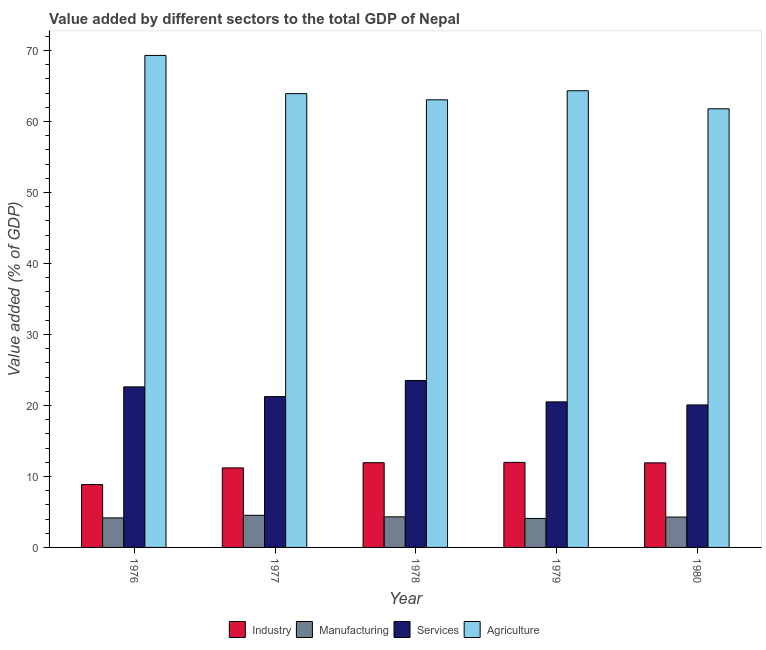How many groups of bars are there?
Provide a succinct answer. 5. Are the number of bars on each tick of the X-axis equal?
Offer a very short reply. Yes. What is the label of the 3rd group of bars from the left?
Provide a succinct answer. 1978. What is the value added by services sector in 1976?
Offer a very short reply. 22.61. Across all years, what is the maximum value added by services sector?
Offer a terse response. 23.51. Across all years, what is the minimum value added by services sector?
Your answer should be compact. 20.07. In which year was the value added by services sector maximum?
Your response must be concise. 1978. In which year was the value added by manufacturing sector minimum?
Ensure brevity in your answer.  1979. What is the total value added by industrial sector in the graph?
Your answer should be compact. 55.89. What is the difference between the value added by services sector in 1976 and that in 1980?
Your response must be concise. 2.54. What is the difference between the value added by agricultural sector in 1976 and the value added by industrial sector in 1980?
Give a very brief answer. 7.52. What is the average value added by services sector per year?
Provide a short and direct response. 21.59. In how many years, is the value added by agricultural sector greater than 64 %?
Offer a very short reply. 2. What is the ratio of the value added by agricultural sector in 1978 to that in 1979?
Offer a very short reply. 0.98. Is the value added by industrial sector in 1976 less than that in 1978?
Provide a succinct answer. Yes. Is the difference between the value added by agricultural sector in 1977 and 1978 greater than the difference between the value added by services sector in 1977 and 1978?
Give a very brief answer. No. What is the difference between the highest and the second highest value added by industrial sector?
Your answer should be very brief. 0.04. What is the difference between the highest and the lowest value added by manufacturing sector?
Make the answer very short. 0.45. Is it the case that in every year, the sum of the value added by services sector and value added by industrial sector is greater than the sum of value added by agricultural sector and value added by manufacturing sector?
Your answer should be compact. No. What does the 2nd bar from the left in 1977 represents?
Ensure brevity in your answer.  Manufacturing. What does the 2nd bar from the right in 1977 represents?
Ensure brevity in your answer.  Services. Is it the case that in every year, the sum of the value added by industrial sector and value added by manufacturing sector is greater than the value added by services sector?
Your answer should be very brief. No. Are all the bars in the graph horizontal?
Give a very brief answer. No. Does the graph contain grids?
Ensure brevity in your answer.  No. How are the legend labels stacked?
Your response must be concise. Horizontal. What is the title of the graph?
Ensure brevity in your answer.  Value added by different sectors to the total GDP of Nepal. What is the label or title of the X-axis?
Give a very brief answer. Year. What is the label or title of the Y-axis?
Your answer should be compact. Value added (% of GDP). What is the Value added (% of GDP) in Industry in 1976?
Your response must be concise. 8.86. What is the Value added (% of GDP) in Manufacturing in 1976?
Your response must be concise. 4.16. What is the Value added (% of GDP) of Services in 1976?
Give a very brief answer. 22.61. What is the Value added (% of GDP) of Agriculture in 1976?
Your response must be concise. 69.29. What is the Value added (% of GDP) in Industry in 1977?
Your response must be concise. 11.2. What is the Value added (% of GDP) of Manufacturing in 1977?
Give a very brief answer. 4.53. What is the Value added (% of GDP) of Services in 1977?
Offer a terse response. 21.24. What is the Value added (% of GDP) of Agriculture in 1977?
Offer a very short reply. 63.91. What is the Value added (% of GDP) of Industry in 1978?
Make the answer very short. 11.93. What is the Value added (% of GDP) in Manufacturing in 1978?
Keep it short and to the point. 4.31. What is the Value added (% of GDP) in Services in 1978?
Your response must be concise. 23.51. What is the Value added (% of GDP) of Agriculture in 1978?
Provide a short and direct response. 63.04. What is the Value added (% of GDP) of Industry in 1979?
Provide a short and direct response. 11.98. What is the Value added (% of GDP) of Manufacturing in 1979?
Make the answer very short. 4.08. What is the Value added (% of GDP) of Services in 1979?
Keep it short and to the point. 20.5. What is the Value added (% of GDP) in Agriculture in 1979?
Keep it short and to the point. 64.32. What is the Value added (% of GDP) in Industry in 1980?
Your answer should be very brief. 11.92. What is the Value added (% of GDP) of Manufacturing in 1980?
Offer a terse response. 4.28. What is the Value added (% of GDP) of Services in 1980?
Your response must be concise. 20.07. What is the Value added (% of GDP) in Agriculture in 1980?
Make the answer very short. 61.77. Across all years, what is the maximum Value added (% of GDP) of Industry?
Provide a short and direct response. 11.98. Across all years, what is the maximum Value added (% of GDP) in Manufacturing?
Your answer should be compact. 4.53. Across all years, what is the maximum Value added (% of GDP) of Services?
Your answer should be compact. 23.51. Across all years, what is the maximum Value added (% of GDP) of Agriculture?
Offer a terse response. 69.29. Across all years, what is the minimum Value added (% of GDP) of Industry?
Provide a short and direct response. 8.86. Across all years, what is the minimum Value added (% of GDP) of Manufacturing?
Your answer should be very brief. 4.08. Across all years, what is the minimum Value added (% of GDP) of Services?
Your answer should be compact. 20.07. Across all years, what is the minimum Value added (% of GDP) in Agriculture?
Your answer should be compact. 61.77. What is the total Value added (% of GDP) of Industry in the graph?
Give a very brief answer. 55.89. What is the total Value added (% of GDP) in Manufacturing in the graph?
Your response must be concise. 21.35. What is the total Value added (% of GDP) in Services in the graph?
Provide a succinct answer. 107.93. What is the total Value added (% of GDP) of Agriculture in the graph?
Offer a very short reply. 322.34. What is the difference between the Value added (% of GDP) of Industry in 1976 and that in 1977?
Provide a succinct answer. -2.35. What is the difference between the Value added (% of GDP) of Manufacturing in 1976 and that in 1977?
Make the answer very short. -0.37. What is the difference between the Value added (% of GDP) in Services in 1976 and that in 1977?
Keep it short and to the point. 1.37. What is the difference between the Value added (% of GDP) of Agriculture in 1976 and that in 1977?
Provide a succinct answer. 5.38. What is the difference between the Value added (% of GDP) in Industry in 1976 and that in 1978?
Your response must be concise. -3.08. What is the difference between the Value added (% of GDP) in Manufacturing in 1976 and that in 1978?
Give a very brief answer. -0.15. What is the difference between the Value added (% of GDP) in Services in 1976 and that in 1978?
Your response must be concise. -0.9. What is the difference between the Value added (% of GDP) in Agriculture in 1976 and that in 1978?
Provide a short and direct response. 6.25. What is the difference between the Value added (% of GDP) in Industry in 1976 and that in 1979?
Ensure brevity in your answer.  -3.12. What is the difference between the Value added (% of GDP) in Manufacturing in 1976 and that in 1979?
Your response must be concise. 0.08. What is the difference between the Value added (% of GDP) in Services in 1976 and that in 1979?
Give a very brief answer. 2.11. What is the difference between the Value added (% of GDP) of Agriculture in 1976 and that in 1979?
Your answer should be compact. 4.97. What is the difference between the Value added (% of GDP) of Industry in 1976 and that in 1980?
Your answer should be compact. -3.06. What is the difference between the Value added (% of GDP) in Manufacturing in 1976 and that in 1980?
Give a very brief answer. -0.12. What is the difference between the Value added (% of GDP) in Services in 1976 and that in 1980?
Your answer should be compact. 2.54. What is the difference between the Value added (% of GDP) in Agriculture in 1976 and that in 1980?
Give a very brief answer. 7.52. What is the difference between the Value added (% of GDP) in Industry in 1977 and that in 1978?
Your response must be concise. -0.73. What is the difference between the Value added (% of GDP) of Manufacturing in 1977 and that in 1978?
Your answer should be very brief. 0.22. What is the difference between the Value added (% of GDP) in Services in 1977 and that in 1978?
Ensure brevity in your answer.  -2.27. What is the difference between the Value added (% of GDP) in Agriculture in 1977 and that in 1978?
Your answer should be very brief. 0.87. What is the difference between the Value added (% of GDP) in Industry in 1977 and that in 1979?
Make the answer very short. -0.78. What is the difference between the Value added (% of GDP) in Manufacturing in 1977 and that in 1979?
Your response must be concise. 0.45. What is the difference between the Value added (% of GDP) of Services in 1977 and that in 1979?
Your answer should be very brief. 0.74. What is the difference between the Value added (% of GDP) in Agriculture in 1977 and that in 1979?
Make the answer very short. -0.41. What is the difference between the Value added (% of GDP) of Industry in 1977 and that in 1980?
Your answer should be very brief. -0.71. What is the difference between the Value added (% of GDP) in Manufacturing in 1977 and that in 1980?
Your answer should be very brief. 0.25. What is the difference between the Value added (% of GDP) in Services in 1977 and that in 1980?
Your answer should be compact. 1.18. What is the difference between the Value added (% of GDP) of Agriculture in 1977 and that in 1980?
Offer a very short reply. 2.14. What is the difference between the Value added (% of GDP) in Industry in 1978 and that in 1979?
Your answer should be very brief. -0.04. What is the difference between the Value added (% of GDP) in Manufacturing in 1978 and that in 1979?
Offer a very short reply. 0.23. What is the difference between the Value added (% of GDP) in Services in 1978 and that in 1979?
Offer a terse response. 3.01. What is the difference between the Value added (% of GDP) in Agriculture in 1978 and that in 1979?
Offer a very short reply. -1.28. What is the difference between the Value added (% of GDP) in Industry in 1978 and that in 1980?
Make the answer very short. 0.02. What is the difference between the Value added (% of GDP) of Manufacturing in 1978 and that in 1980?
Ensure brevity in your answer.  0.03. What is the difference between the Value added (% of GDP) of Services in 1978 and that in 1980?
Ensure brevity in your answer.  3.44. What is the difference between the Value added (% of GDP) of Agriculture in 1978 and that in 1980?
Your answer should be very brief. 1.27. What is the difference between the Value added (% of GDP) in Industry in 1979 and that in 1980?
Provide a short and direct response. 0.06. What is the difference between the Value added (% of GDP) of Manufacturing in 1979 and that in 1980?
Make the answer very short. -0.2. What is the difference between the Value added (% of GDP) in Services in 1979 and that in 1980?
Your answer should be compact. 0.43. What is the difference between the Value added (% of GDP) of Agriculture in 1979 and that in 1980?
Your answer should be very brief. 2.55. What is the difference between the Value added (% of GDP) in Industry in 1976 and the Value added (% of GDP) in Manufacturing in 1977?
Offer a very short reply. 4.33. What is the difference between the Value added (% of GDP) of Industry in 1976 and the Value added (% of GDP) of Services in 1977?
Provide a succinct answer. -12.39. What is the difference between the Value added (% of GDP) of Industry in 1976 and the Value added (% of GDP) of Agriculture in 1977?
Keep it short and to the point. -55.06. What is the difference between the Value added (% of GDP) of Manufacturing in 1976 and the Value added (% of GDP) of Services in 1977?
Give a very brief answer. -17.08. What is the difference between the Value added (% of GDP) of Manufacturing in 1976 and the Value added (% of GDP) of Agriculture in 1977?
Offer a terse response. -59.75. What is the difference between the Value added (% of GDP) of Services in 1976 and the Value added (% of GDP) of Agriculture in 1977?
Offer a very short reply. -41.3. What is the difference between the Value added (% of GDP) of Industry in 1976 and the Value added (% of GDP) of Manufacturing in 1978?
Offer a terse response. 4.55. What is the difference between the Value added (% of GDP) of Industry in 1976 and the Value added (% of GDP) of Services in 1978?
Provide a succinct answer. -14.66. What is the difference between the Value added (% of GDP) of Industry in 1976 and the Value added (% of GDP) of Agriculture in 1978?
Provide a succinct answer. -54.19. What is the difference between the Value added (% of GDP) in Manufacturing in 1976 and the Value added (% of GDP) in Services in 1978?
Provide a succinct answer. -19.35. What is the difference between the Value added (% of GDP) of Manufacturing in 1976 and the Value added (% of GDP) of Agriculture in 1978?
Make the answer very short. -58.88. What is the difference between the Value added (% of GDP) in Services in 1976 and the Value added (% of GDP) in Agriculture in 1978?
Offer a very short reply. -40.43. What is the difference between the Value added (% of GDP) of Industry in 1976 and the Value added (% of GDP) of Manufacturing in 1979?
Offer a terse response. 4.77. What is the difference between the Value added (% of GDP) in Industry in 1976 and the Value added (% of GDP) in Services in 1979?
Your response must be concise. -11.64. What is the difference between the Value added (% of GDP) of Industry in 1976 and the Value added (% of GDP) of Agriculture in 1979?
Your answer should be compact. -55.46. What is the difference between the Value added (% of GDP) of Manufacturing in 1976 and the Value added (% of GDP) of Services in 1979?
Your response must be concise. -16.34. What is the difference between the Value added (% of GDP) of Manufacturing in 1976 and the Value added (% of GDP) of Agriculture in 1979?
Keep it short and to the point. -60.16. What is the difference between the Value added (% of GDP) of Services in 1976 and the Value added (% of GDP) of Agriculture in 1979?
Ensure brevity in your answer.  -41.71. What is the difference between the Value added (% of GDP) of Industry in 1976 and the Value added (% of GDP) of Manufacturing in 1980?
Ensure brevity in your answer.  4.58. What is the difference between the Value added (% of GDP) in Industry in 1976 and the Value added (% of GDP) in Services in 1980?
Ensure brevity in your answer.  -11.21. What is the difference between the Value added (% of GDP) in Industry in 1976 and the Value added (% of GDP) in Agriculture in 1980?
Offer a very short reply. -52.92. What is the difference between the Value added (% of GDP) of Manufacturing in 1976 and the Value added (% of GDP) of Services in 1980?
Ensure brevity in your answer.  -15.91. What is the difference between the Value added (% of GDP) of Manufacturing in 1976 and the Value added (% of GDP) of Agriculture in 1980?
Keep it short and to the point. -57.62. What is the difference between the Value added (% of GDP) of Services in 1976 and the Value added (% of GDP) of Agriculture in 1980?
Your answer should be compact. -39.16. What is the difference between the Value added (% of GDP) of Industry in 1977 and the Value added (% of GDP) of Manufacturing in 1978?
Offer a very short reply. 6.89. What is the difference between the Value added (% of GDP) in Industry in 1977 and the Value added (% of GDP) in Services in 1978?
Offer a terse response. -12.31. What is the difference between the Value added (% of GDP) in Industry in 1977 and the Value added (% of GDP) in Agriculture in 1978?
Offer a terse response. -51.84. What is the difference between the Value added (% of GDP) of Manufacturing in 1977 and the Value added (% of GDP) of Services in 1978?
Offer a very short reply. -18.98. What is the difference between the Value added (% of GDP) in Manufacturing in 1977 and the Value added (% of GDP) in Agriculture in 1978?
Provide a short and direct response. -58.51. What is the difference between the Value added (% of GDP) in Services in 1977 and the Value added (% of GDP) in Agriculture in 1978?
Ensure brevity in your answer.  -41.8. What is the difference between the Value added (% of GDP) in Industry in 1977 and the Value added (% of GDP) in Manufacturing in 1979?
Make the answer very short. 7.12. What is the difference between the Value added (% of GDP) in Industry in 1977 and the Value added (% of GDP) in Services in 1979?
Your answer should be compact. -9.3. What is the difference between the Value added (% of GDP) in Industry in 1977 and the Value added (% of GDP) in Agriculture in 1979?
Give a very brief answer. -53.12. What is the difference between the Value added (% of GDP) of Manufacturing in 1977 and the Value added (% of GDP) of Services in 1979?
Your answer should be compact. -15.97. What is the difference between the Value added (% of GDP) in Manufacturing in 1977 and the Value added (% of GDP) in Agriculture in 1979?
Ensure brevity in your answer.  -59.79. What is the difference between the Value added (% of GDP) of Services in 1977 and the Value added (% of GDP) of Agriculture in 1979?
Provide a short and direct response. -43.08. What is the difference between the Value added (% of GDP) in Industry in 1977 and the Value added (% of GDP) in Manufacturing in 1980?
Keep it short and to the point. 6.93. What is the difference between the Value added (% of GDP) of Industry in 1977 and the Value added (% of GDP) of Services in 1980?
Give a very brief answer. -8.87. What is the difference between the Value added (% of GDP) of Industry in 1977 and the Value added (% of GDP) of Agriculture in 1980?
Your answer should be very brief. -50.57. What is the difference between the Value added (% of GDP) of Manufacturing in 1977 and the Value added (% of GDP) of Services in 1980?
Your response must be concise. -15.54. What is the difference between the Value added (% of GDP) in Manufacturing in 1977 and the Value added (% of GDP) in Agriculture in 1980?
Offer a very short reply. -57.25. What is the difference between the Value added (% of GDP) of Services in 1977 and the Value added (% of GDP) of Agriculture in 1980?
Your answer should be compact. -40.53. What is the difference between the Value added (% of GDP) of Industry in 1978 and the Value added (% of GDP) of Manufacturing in 1979?
Offer a terse response. 7.85. What is the difference between the Value added (% of GDP) in Industry in 1978 and the Value added (% of GDP) in Services in 1979?
Give a very brief answer. -8.56. What is the difference between the Value added (% of GDP) in Industry in 1978 and the Value added (% of GDP) in Agriculture in 1979?
Your response must be concise. -52.39. What is the difference between the Value added (% of GDP) in Manufacturing in 1978 and the Value added (% of GDP) in Services in 1979?
Your response must be concise. -16.19. What is the difference between the Value added (% of GDP) in Manufacturing in 1978 and the Value added (% of GDP) in Agriculture in 1979?
Offer a very short reply. -60.01. What is the difference between the Value added (% of GDP) in Services in 1978 and the Value added (% of GDP) in Agriculture in 1979?
Make the answer very short. -40.81. What is the difference between the Value added (% of GDP) in Industry in 1978 and the Value added (% of GDP) in Manufacturing in 1980?
Give a very brief answer. 7.66. What is the difference between the Value added (% of GDP) in Industry in 1978 and the Value added (% of GDP) in Services in 1980?
Give a very brief answer. -8.13. What is the difference between the Value added (% of GDP) in Industry in 1978 and the Value added (% of GDP) in Agriculture in 1980?
Make the answer very short. -49.84. What is the difference between the Value added (% of GDP) of Manufacturing in 1978 and the Value added (% of GDP) of Services in 1980?
Your answer should be compact. -15.76. What is the difference between the Value added (% of GDP) in Manufacturing in 1978 and the Value added (% of GDP) in Agriculture in 1980?
Your response must be concise. -57.47. What is the difference between the Value added (% of GDP) in Services in 1978 and the Value added (% of GDP) in Agriculture in 1980?
Offer a very short reply. -38.26. What is the difference between the Value added (% of GDP) of Industry in 1979 and the Value added (% of GDP) of Manufacturing in 1980?
Give a very brief answer. 7.7. What is the difference between the Value added (% of GDP) in Industry in 1979 and the Value added (% of GDP) in Services in 1980?
Provide a short and direct response. -8.09. What is the difference between the Value added (% of GDP) of Industry in 1979 and the Value added (% of GDP) of Agriculture in 1980?
Keep it short and to the point. -49.8. What is the difference between the Value added (% of GDP) in Manufacturing in 1979 and the Value added (% of GDP) in Services in 1980?
Provide a succinct answer. -15.99. What is the difference between the Value added (% of GDP) of Manufacturing in 1979 and the Value added (% of GDP) of Agriculture in 1980?
Offer a very short reply. -57.69. What is the difference between the Value added (% of GDP) in Services in 1979 and the Value added (% of GDP) in Agriculture in 1980?
Your answer should be compact. -41.28. What is the average Value added (% of GDP) in Industry per year?
Your response must be concise. 11.18. What is the average Value added (% of GDP) in Manufacturing per year?
Keep it short and to the point. 4.27. What is the average Value added (% of GDP) in Services per year?
Your answer should be very brief. 21.59. What is the average Value added (% of GDP) in Agriculture per year?
Ensure brevity in your answer.  64.47. In the year 1976, what is the difference between the Value added (% of GDP) in Industry and Value added (% of GDP) in Manufacturing?
Your answer should be compact. 4.7. In the year 1976, what is the difference between the Value added (% of GDP) of Industry and Value added (% of GDP) of Services?
Your answer should be very brief. -13.75. In the year 1976, what is the difference between the Value added (% of GDP) in Industry and Value added (% of GDP) in Agriculture?
Your response must be concise. -60.44. In the year 1976, what is the difference between the Value added (% of GDP) in Manufacturing and Value added (% of GDP) in Services?
Your answer should be compact. -18.45. In the year 1976, what is the difference between the Value added (% of GDP) in Manufacturing and Value added (% of GDP) in Agriculture?
Offer a very short reply. -65.13. In the year 1976, what is the difference between the Value added (% of GDP) of Services and Value added (% of GDP) of Agriculture?
Your answer should be compact. -46.68. In the year 1977, what is the difference between the Value added (% of GDP) of Industry and Value added (% of GDP) of Manufacturing?
Keep it short and to the point. 6.67. In the year 1977, what is the difference between the Value added (% of GDP) in Industry and Value added (% of GDP) in Services?
Your response must be concise. -10.04. In the year 1977, what is the difference between the Value added (% of GDP) in Industry and Value added (% of GDP) in Agriculture?
Your response must be concise. -52.71. In the year 1977, what is the difference between the Value added (% of GDP) of Manufacturing and Value added (% of GDP) of Services?
Provide a short and direct response. -16.72. In the year 1977, what is the difference between the Value added (% of GDP) in Manufacturing and Value added (% of GDP) in Agriculture?
Make the answer very short. -59.38. In the year 1977, what is the difference between the Value added (% of GDP) of Services and Value added (% of GDP) of Agriculture?
Offer a terse response. -42.67. In the year 1978, what is the difference between the Value added (% of GDP) in Industry and Value added (% of GDP) in Manufacturing?
Give a very brief answer. 7.63. In the year 1978, what is the difference between the Value added (% of GDP) in Industry and Value added (% of GDP) in Services?
Make the answer very short. -11.58. In the year 1978, what is the difference between the Value added (% of GDP) of Industry and Value added (% of GDP) of Agriculture?
Make the answer very short. -51.11. In the year 1978, what is the difference between the Value added (% of GDP) in Manufacturing and Value added (% of GDP) in Services?
Your answer should be compact. -19.2. In the year 1978, what is the difference between the Value added (% of GDP) of Manufacturing and Value added (% of GDP) of Agriculture?
Offer a very short reply. -58.73. In the year 1978, what is the difference between the Value added (% of GDP) of Services and Value added (% of GDP) of Agriculture?
Make the answer very short. -39.53. In the year 1979, what is the difference between the Value added (% of GDP) of Industry and Value added (% of GDP) of Manufacturing?
Make the answer very short. 7.9. In the year 1979, what is the difference between the Value added (% of GDP) in Industry and Value added (% of GDP) in Services?
Provide a short and direct response. -8.52. In the year 1979, what is the difference between the Value added (% of GDP) of Industry and Value added (% of GDP) of Agriculture?
Give a very brief answer. -52.34. In the year 1979, what is the difference between the Value added (% of GDP) in Manufacturing and Value added (% of GDP) in Services?
Ensure brevity in your answer.  -16.42. In the year 1979, what is the difference between the Value added (% of GDP) of Manufacturing and Value added (% of GDP) of Agriculture?
Provide a succinct answer. -60.24. In the year 1979, what is the difference between the Value added (% of GDP) of Services and Value added (% of GDP) of Agriculture?
Your response must be concise. -43.82. In the year 1980, what is the difference between the Value added (% of GDP) of Industry and Value added (% of GDP) of Manufacturing?
Keep it short and to the point. 7.64. In the year 1980, what is the difference between the Value added (% of GDP) in Industry and Value added (% of GDP) in Services?
Keep it short and to the point. -8.15. In the year 1980, what is the difference between the Value added (% of GDP) in Industry and Value added (% of GDP) in Agriculture?
Ensure brevity in your answer.  -49.86. In the year 1980, what is the difference between the Value added (% of GDP) in Manufacturing and Value added (% of GDP) in Services?
Make the answer very short. -15.79. In the year 1980, what is the difference between the Value added (% of GDP) of Manufacturing and Value added (% of GDP) of Agriculture?
Provide a short and direct response. -57.5. In the year 1980, what is the difference between the Value added (% of GDP) of Services and Value added (% of GDP) of Agriculture?
Give a very brief answer. -41.71. What is the ratio of the Value added (% of GDP) of Industry in 1976 to that in 1977?
Ensure brevity in your answer.  0.79. What is the ratio of the Value added (% of GDP) of Manufacturing in 1976 to that in 1977?
Ensure brevity in your answer.  0.92. What is the ratio of the Value added (% of GDP) of Services in 1976 to that in 1977?
Your response must be concise. 1.06. What is the ratio of the Value added (% of GDP) of Agriculture in 1976 to that in 1977?
Give a very brief answer. 1.08. What is the ratio of the Value added (% of GDP) in Industry in 1976 to that in 1978?
Provide a succinct answer. 0.74. What is the ratio of the Value added (% of GDP) in Manufacturing in 1976 to that in 1978?
Your response must be concise. 0.97. What is the ratio of the Value added (% of GDP) in Services in 1976 to that in 1978?
Keep it short and to the point. 0.96. What is the ratio of the Value added (% of GDP) of Agriculture in 1976 to that in 1978?
Offer a terse response. 1.1. What is the ratio of the Value added (% of GDP) of Industry in 1976 to that in 1979?
Provide a succinct answer. 0.74. What is the ratio of the Value added (% of GDP) of Manufacturing in 1976 to that in 1979?
Your answer should be very brief. 1.02. What is the ratio of the Value added (% of GDP) of Services in 1976 to that in 1979?
Provide a succinct answer. 1.1. What is the ratio of the Value added (% of GDP) in Agriculture in 1976 to that in 1979?
Your answer should be very brief. 1.08. What is the ratio of the Value added (% of GDP) in Industry in 1976 to that in 1980?
Provide a short and direct response. 0.74. What is the ratio of the Value added (% of GDP) in Manufacturing in 1976 to that in 1980?
Your response must be concise. 0.97. What is the ratio of the Value added (% of GDP) in Services in 1976 to that in 1980?
Give a very brief answer. 1.13. What is the ratio of the Value added (% of GDP) in Agriculture in 1976 to that in 1980?
Give a very brief answer. 1.12. What is the ratio of the Value added (% of GDP) of Industry in 1977 to that in 1978?
Provide a succinct answer. 0.94. What is the ratio of the Value added (% of GDP) of Manufacturing in 1977 to that in 1978?
Give a very brief answer. 1.05. What is the ratio of the Value added (% of GDP) of Services in 1977 to that in 1978?
Offer a terse response. 0.9. What is the ratio of the Value added (% of GDP) of Agriculture in 1977 to that in 1978?
Provide a short and direct response. 1.01. What is the ratio of the Value added (% of GDP) of Industry in 1977 to that in 1979?
Provide a short and direct response. 0.94. What is the ratio of the Value added (% of GDP) of Manufacturing in 1977 to that in 1979?
Make the answer very short. 1.11. What is the ratio of the Value added (% of GDP) in Services in 1977 to that in 1979?
Offer a terse response. 1.04. What is the ratio of the Value added (% of GDP) of Agriculture in 1977 to that in 1979?
Your answer should be compact. 0.99. What is the ratio of the Value added (% of GDP) of Industry in 1977 to that in 1980?
Make the answer very short. 0.94. What is the ratio of the Value added (% of GDP) in Manufacturing in 1977 to that in 1980?
Your response must be concise. 1.06. What is the ratio of the Value added (% of GDP) in Services in 1977 to that in 1980?
Your answer should be very brief. 1.06. What is the ratio of the Value added (% of GDP) of Agriculture in 1977 to that in 1980?
Your answer should be very brief. 1.03. What is the ratio of the Value added (% of GDP) in Industry in 1978 to that in 1979?
Your answer should be very brief. 1. What is the ratio of the Value added (% of GDP) in Manufacturing in 1978 to that in 1979?
Keep it short and to the point. 1.06. What is the ratio of the Value added (% of GDP) of Services in 1978 to that in 1979?
Your answer should be very brief. 1.15. What is the ratio of the Value added (% of GDP) of Agriculture in 1978 to that in 1979?
Provide a succinct answer. 0.98. What is the ratio of the Value added (% of GDP) of Manufacturing in 1978 to that in 1980?
Provide a short and direct response. 1.01. What is the ratio of the Value added (% of GDP) in Services in 1978 to that in 1980?
Provide a short and direct response. 1.17. What is the ratio of the Value added (% of GDP) in Agriculture in 1978 to that in 1980?
Offer a terse response. 1.02. What is the ratio of the Value added (% of GDP) of Manufacturing in 1979 to that in 1980?
Your response must be concise. 0.95. What is the ratio of the Value added (% of GDP) of Services in 1979 to that in 1980?
Ensure brevity in your answer.  1.02. What is the ratio of the Value added (% of GDP) in Agriculture in 1979 to that in 1980?
Ensure brevity in your answer.  1.04. What is the difference between the highest and the second highest Value added (% of GDP) of Industry?
Offer a terse response. 0.04. What is the difference between the highest and the second highest Value added (% of GDP) in Manufacturing?
Ensure brevity in your answer.  0.22. What is the difference between the highest and the second highest Value added (% of GDP) of Services?
Keep it short and to the point. 0.9. What is the difference between the highest and the second highest Value added (% of GDP) of Agriculture?
Your answer should be compact. 4.97. What is the difference between the highest and the lowest Value added (% of GDP) in Industry?
Offer a very short reply. 3.12. What is the difference between the highest and the lowest Value added (% of GDP) of Manufacturing?
Offer a terse response. 0.45. What is the difference between the highest and the lowest Value added (% of GDP) of Services?
Provide a succinct answer. 3.44. What is the difference between the highest and the lowest Value added (% of GDP) of Agriculture?
Keep it short and to the point. 7.52. 